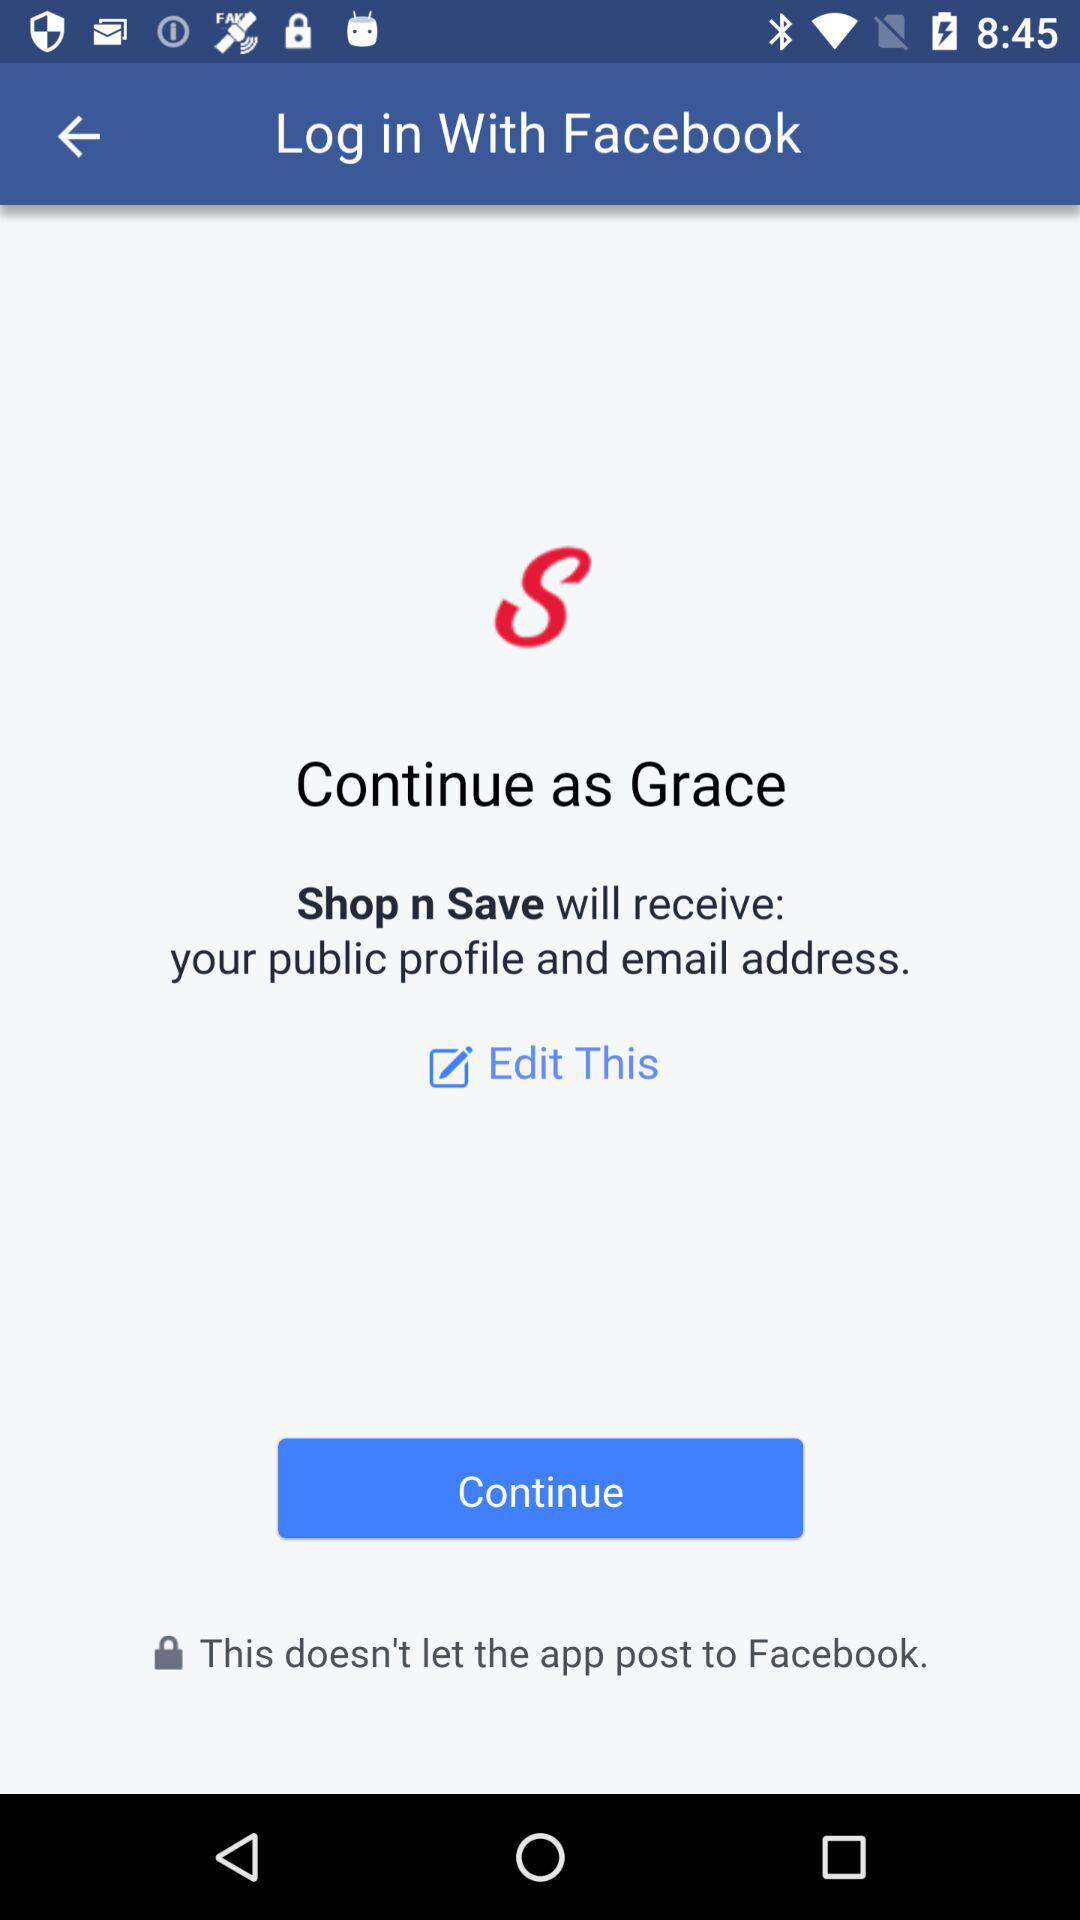What is the user name? The user name is Grace. 